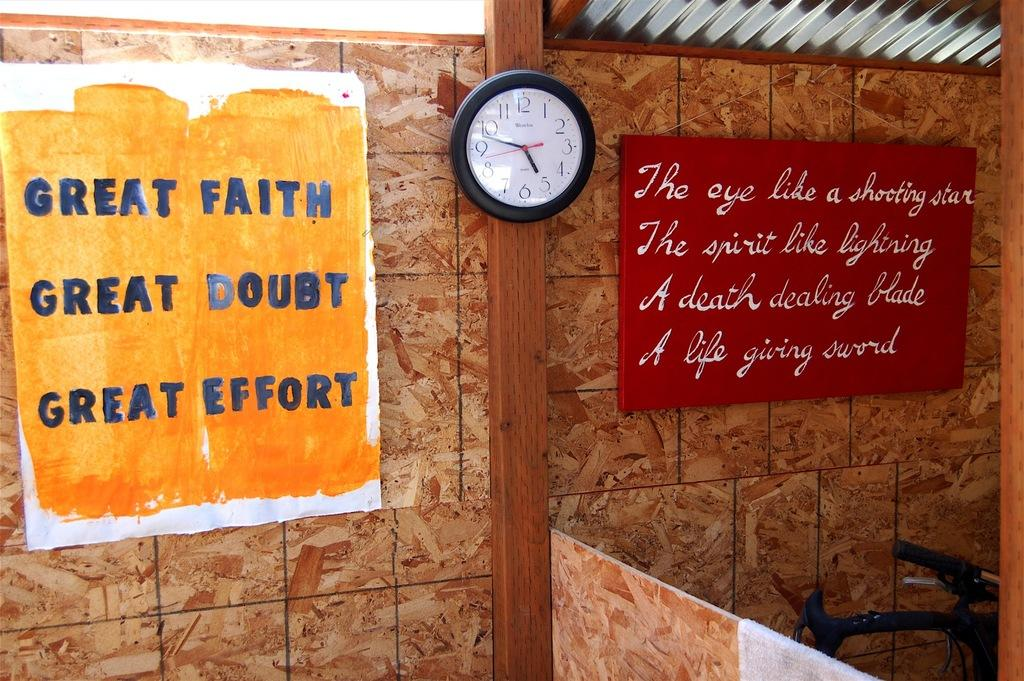<image>
Present a compact description of the photo's key features. A clock is between two signs that have motivational sayings on them. 